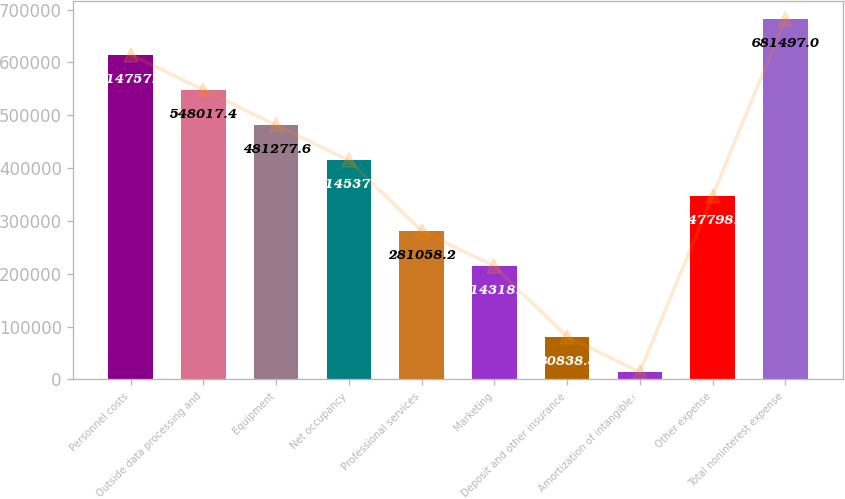Convert chart. <chart><loc_0><loc_0><loc_500><loc_500><bar_chart><fcel>Personnel costs<fcel>Outside data processing and<fcel>Equipment<fcel>Net occupancy<fcel>Professional services<fcel>Marketing<fcel>Deposit and other insurance<fcel>Amortization of intangibles<fcel>Other expense<fcel>Total noninterest expense<nl><fcel>614757<fcel>548017<fcel>481278<fcel>414538<fcel>281058<fcel>214318<fcel>80838.8<fcel>14099<fcel>347798<fcel>681497<nl></chart> 